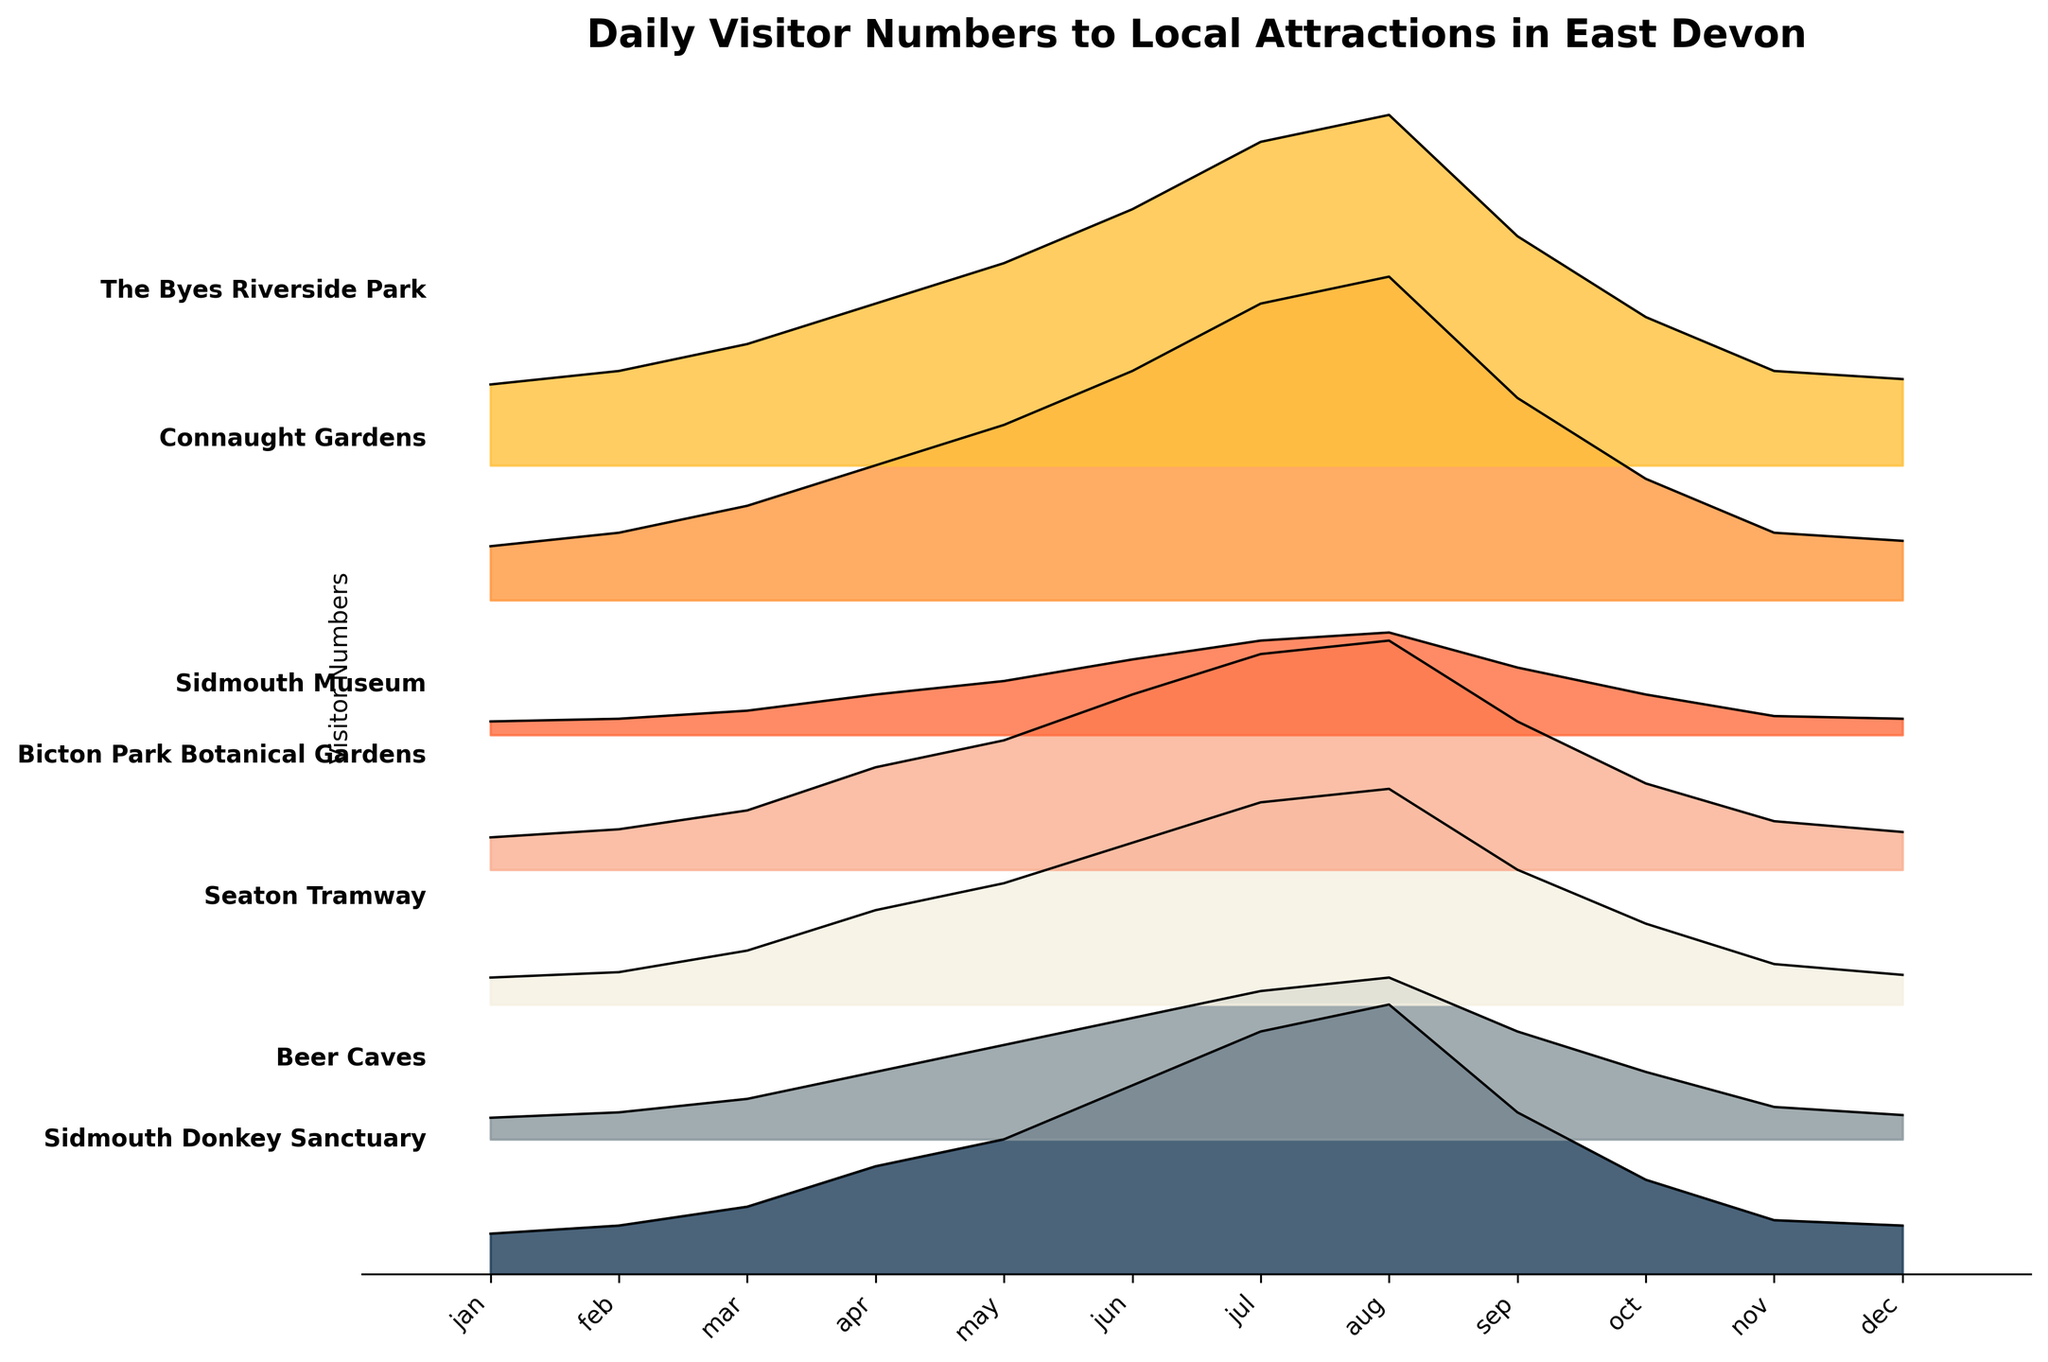What's the title of the figure? The title is usually displayed at the top of the figure.
Answer: Daily Visitor Numbers to Local Attractions in East Devon Which months show the highest visitor numbers across all attractions? By examining the peaks of each ridgeline, the highest visitor numbers generally occur in July and August. These months show the highest ridges across most attractions.
Answer: July and August Which attraction has the highest peak visitor number, and in which month does it occur? The highest peak belongs to 'The Byes Riverside Park' in August where the ridgeline is at its highest.
Answer: The Byes Riverside Park, August Which attraction has the lowest number of visitors in January? From the ridgeline plot, the lowest base at the January tick is 'Sidmouth Museum'.
Answer: Sidmouth Museum During which month does Sidmouth Donkey Sanctuary see a noticeable increase in visitor numbers? There is a sharp increase between March and April as observed from the rising slope of the ridge.
Answer: April How does the visitor number trend for Beer Caves compare between May and August? The ridgeline for Beer Caves shows an increasing trend from May to August with peaks in August.
Answer: Increasing trend Which attraction has the most consistent visitor numbers throughout the year? The ridgelines for 'The Byes Riverside Park' and 'Connaught Gardens' display more uniform increases and decreases compared to other attractions.
Answer: The Byes Riverside Park or Connaught Gardens What is the rough range of visitor numbers for Seaton Tramway in July? The ridgeline for Seaton Tramway in July starts around 300 and peaks around 750.
Answer: Approximately 300 to 750 How does visitor number in December compare across attractions? In December, 'The Byes Riverside Park' consistently shows the highest numbers with other attractions like 'Connaught Gardens' and 'Sidmouth Donkey Sanctuary' following. Sidmouth Museum has the lowest numbers.
Answer: The Byes Riverside Park has the highest; Sidmouth Museum has the lowest How much higher are visitor numbers to Connaught Gardens in August compared to February? The ridgeline for Connaught Gardens in August is around 1200, whereas in February it is around 250, making it a difference of about 950.
Answer: 950 